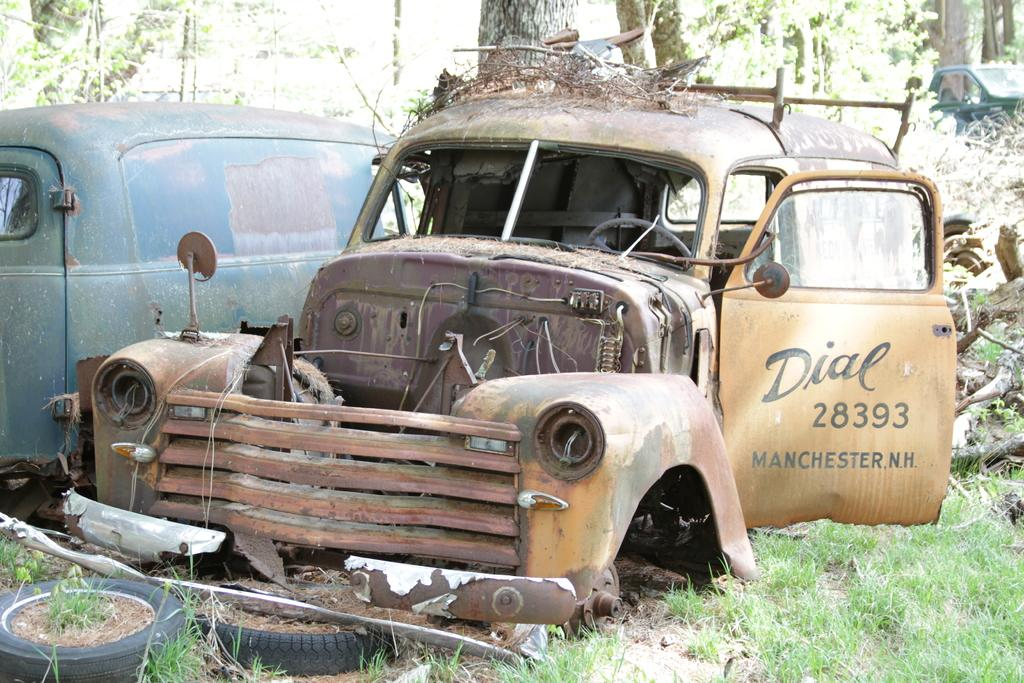What type of vehicles can be seen in the image? There are abandoned vehicles in the image. What part of the vehicles is visible in the image? There are tyres visible in the image. What type of vegetation is present in the image? There are trees in the image. What type of ground cover can be seen in the image? There is grass on the ground in the image. Where is the fifth vehicle located in the image? There is no mention of a fifth vehicle in the image, as only abandoned vehicles are mentioned. 